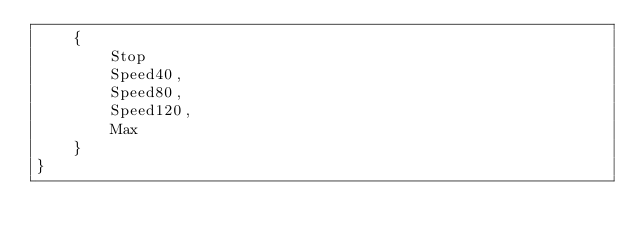<code> <loc_0><loc_0><loc_500><loc_500><_ObjectiveC_>    {
        Stop
        Speed40,
        Speed80,
        Speed120,
        Max
    }
}
</code> 